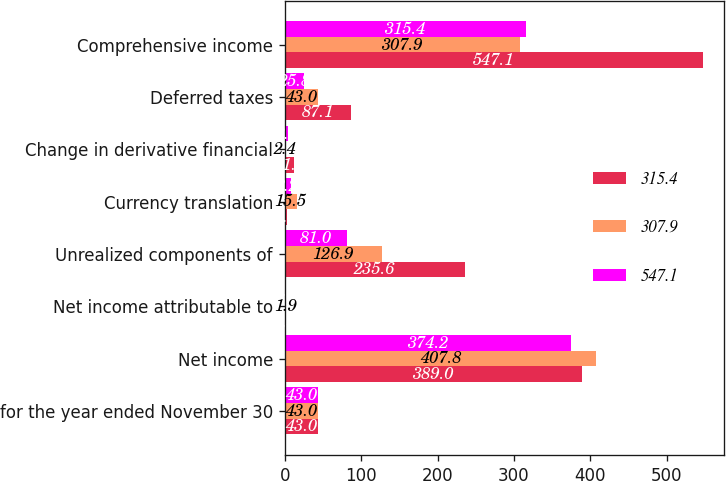<chart> <loc_0><loc_0><loc_500><loc_500><stacked_bar_chart><ecel><fcel>for the year ended November 30<fcel>Net income<fcel>Net income attributable to<fcel>Unrealized components of<fcel>Currency translation<fcel>Change in derivative financial<fcel>Deferred taxes<fcel>Comprehensive income<nl><fcel>315.4<fcel>43<fcel>389<fcel>1.3<fcel>235.6<fcel>3.5<fcel>11.8<fcel>87.1<fcel>547.1<nl><fcel>307.9<fcel>43<fcel>407.8<fcel>1.9<fcel>126.9<fcel>15.5<fcel>2.4<fcel>43<fcel>307.9<nl><fcel>547.1<fcel>43<fcel>374.2<fcel>0.8<fcel>81<fcel>8.2<fcel>3.8<fcel>25.8<fcel>315.4<nl></chart> 